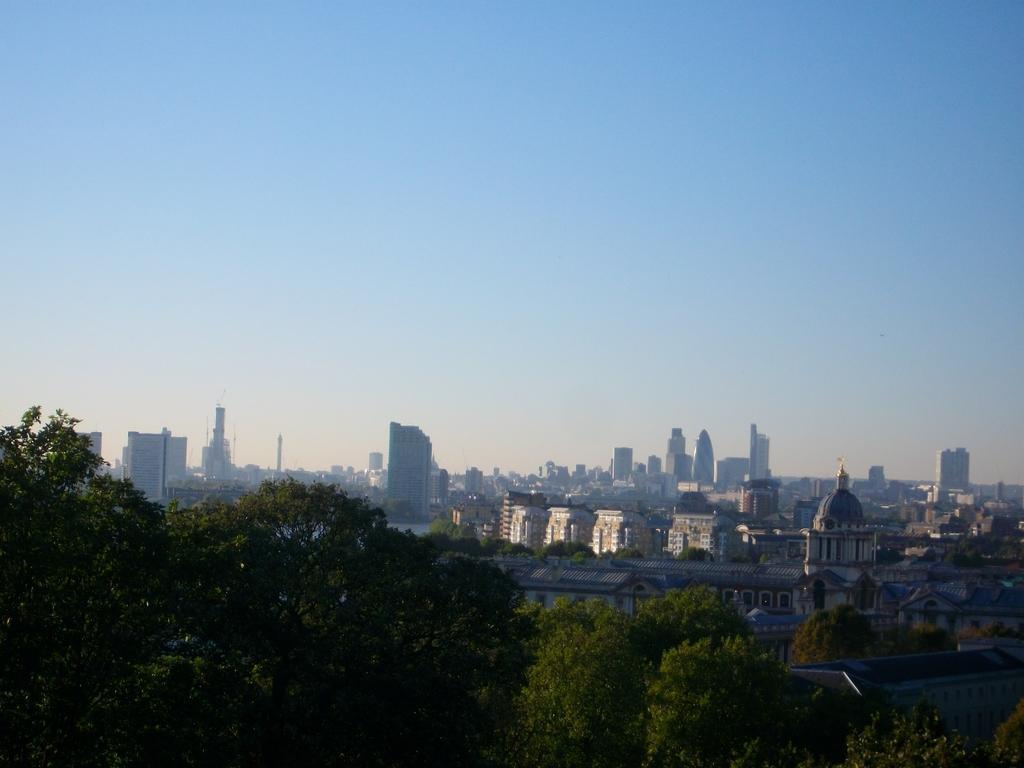How would you summarize this image in a sentence or two? In this image there are trees at the bottom. In the background there are so many buildings one beside the other. At the top there is the sky. It looks like a scenery. 